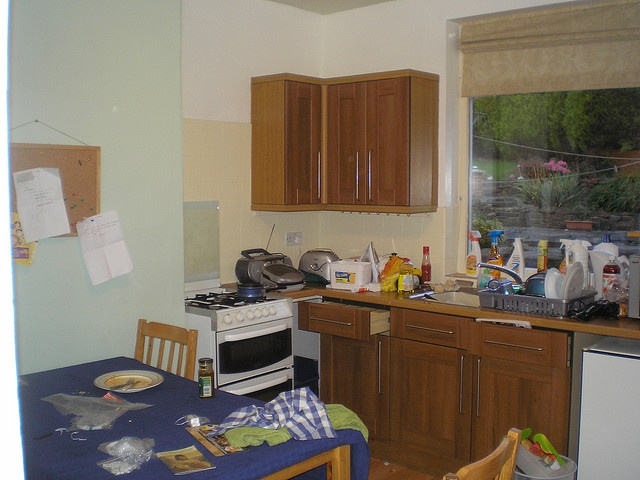Describe the objects in this image and their specific colors. I can see dining table in white, navy, gray, darkblue, and darkgray tones, oven in white, darkgray, black, and gray tones, chair in white, gray, olive, and maroon tones, chair in white, olive, darkgray, brown, and gray tones, and book in white, gray, and olive tones in this image. 